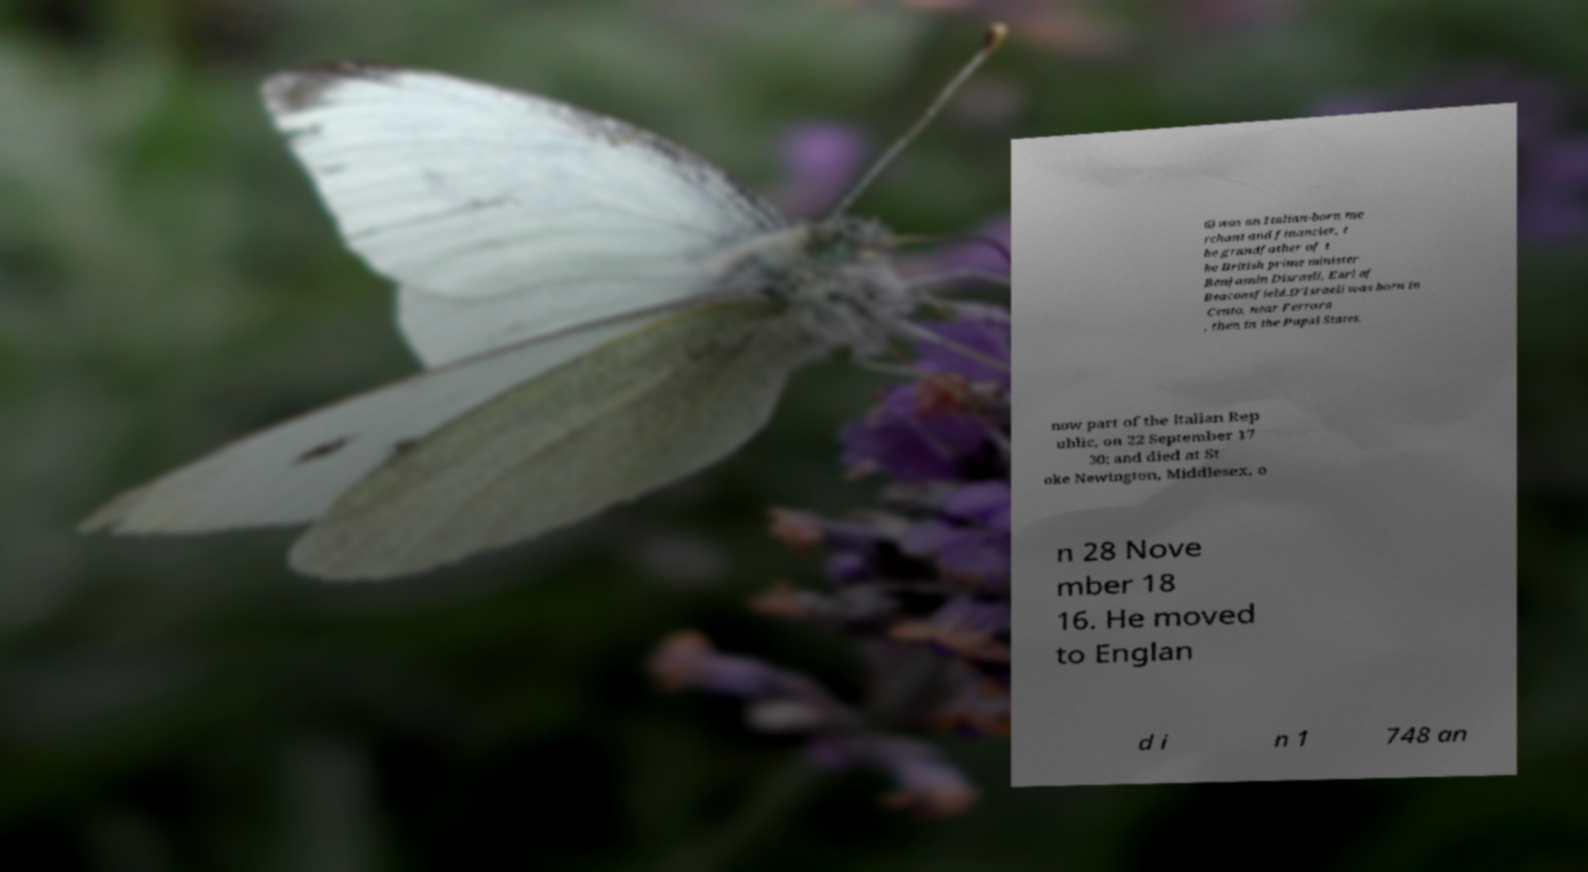I need the written content from this picture converted into text. Can you do that? 6) was an Italian-born me rchant and financier, t he grandfather of t he British prime minister Benjamin Disraeli, Earl of Beaconsfield.D'Israeli was born in Cento, near Ferrara , then in the Papal States, now part of the Italian Rep ublic, on 22 September 17 30; and died at St oke Newington, Middlesex, o n 28 Nove mber 18 16. He moved to Englan d i n 1 748 an 